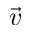Convert formula to latex. <formula><loc_0><loc_0><loc_500><loc_500>\vec { v }</formula> 